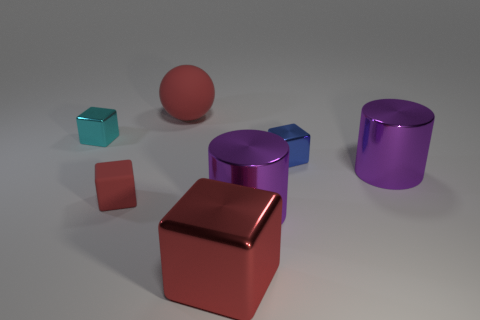There is another blue object that is the same shape as the small matte object; what size is it? The other blue object shares the cube-shaped geometry with the small matte object. It is larger in size, likely medium compared to the small one. 